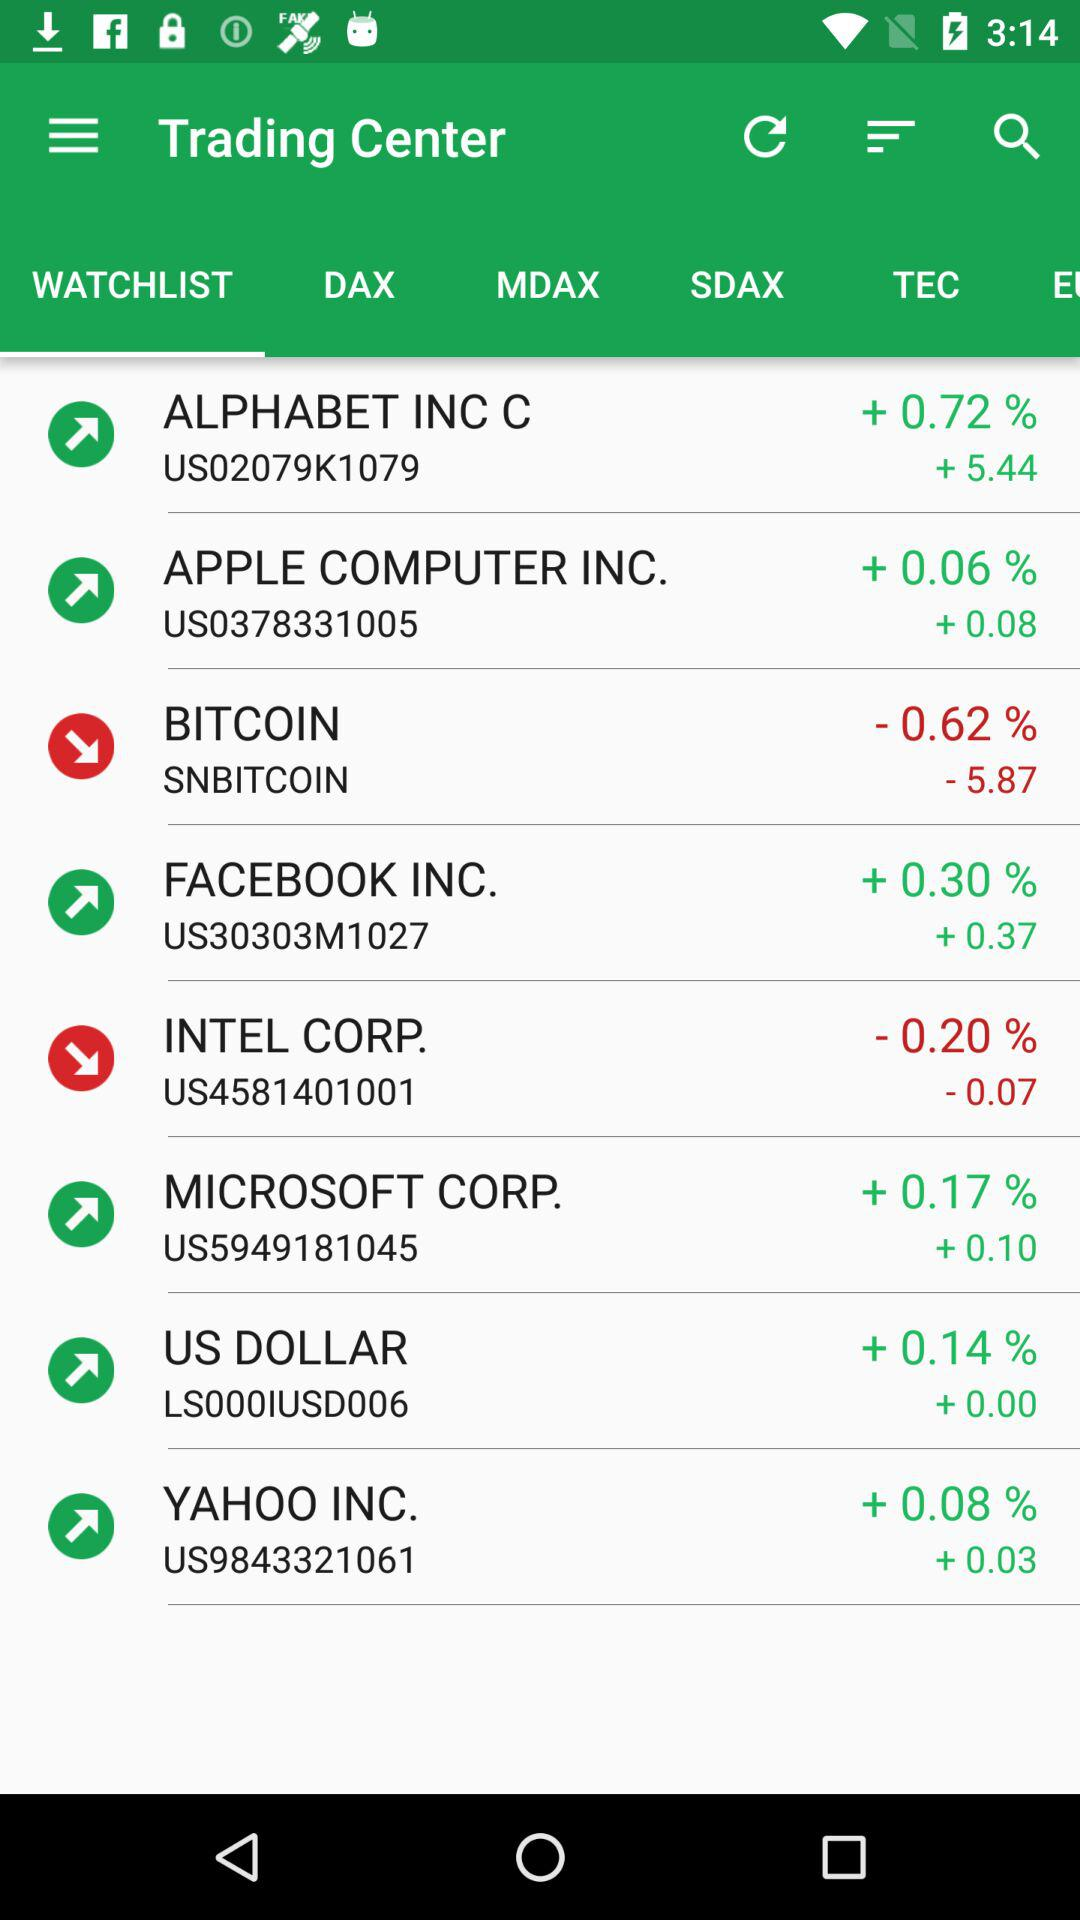What percentage of the "US dollar" has increased? The percentage has increased by +0.14. 